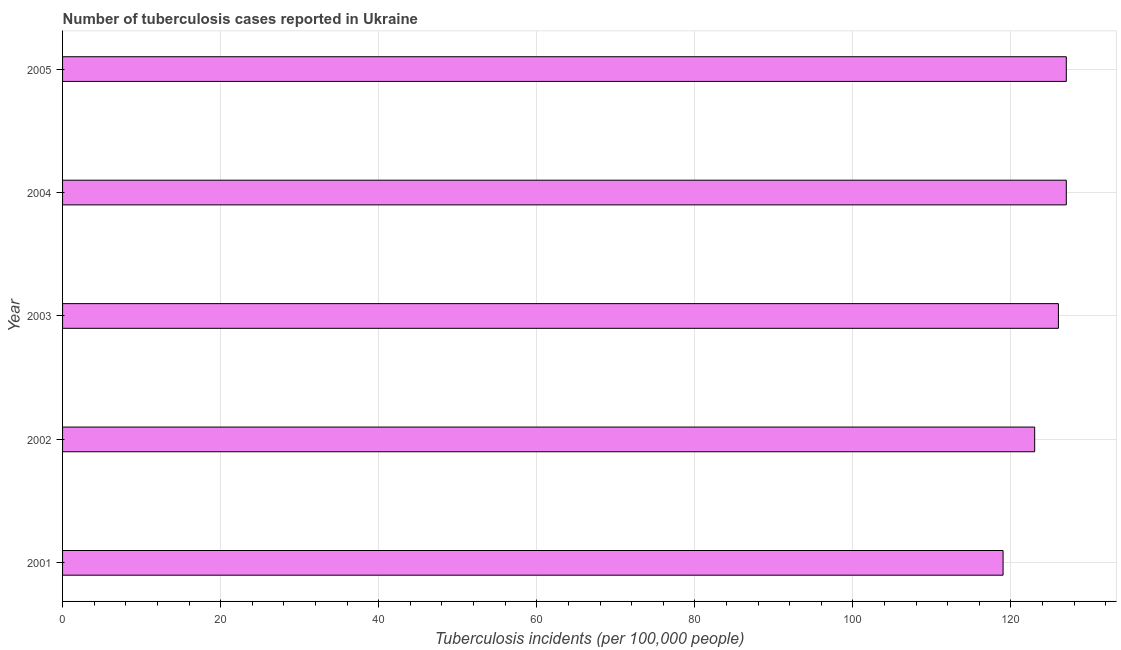Does the graph contain any zero values?
Your answer should be compact. No. Does the graph contain grids?
Provide a short and direct response. Yes. What is the title of the graph?
Ensure brevity in your answer.  Number of tuberculosis cases reported in Ukraine. What is the label or title of the X-axis?
Make the answer very short. Tuberculosis incidents (per 100,0 people). What is the number of tuberculosis incidents in 2004?
Provide a short and direct response. 127. Across all years, what is the maximum number of tuberculosis incidents?
Provide a succinct answer. 127. Across all years, what is the minimum number of tuberculosis incidents?
Provide a succinct answer. 119. In which year was the number of tuberculosis incidents minimum?
Your answer should be compact. 2001. What is the sum of the number of tuberculosis incidents?
Offer a terse response. 622. What is the average number of tuberculosis incidents per year?
Make the answer very short. 124. What is the median number of tuberculosis incidents?
Provide a succinct answer. 126. Do a majority of the years between 2001 and 2005 (inclusive) have number of tuberculosis incidents greater than 56 ?
Provide a succinct answer. Yes. Is the difference between the number of tuberculosis incidents in 2002 and 2003 greater than the difference between any two years?
Your response must be concise. No. Is the sum of the number of tuberculosis incidents in 2003 and 2004 greater than the maximum number of tuberculosis incidents across all years?
Make the answer very short. Yes. In how many years, is the number of tuberculosis incidents greater than the average number of tuberculosis incidents taken over all years?
Your response must be concise. 3. Are the values on the major ticks of X-axis written in scientific E-notation?
Offer a terse response. No. What is the Tuberculosis incidents (per 100,000 people) of 2001?
Offer a terse response. 119. What is the Tuberculosis incidents (per 100,000 people) in 2002?
Keep it short and to the point. 123. What is the Tuberculosis incidents (per 100,000 people) in 2003?
Your response must be concise. 126. What is the Tuberculosis incidents (per 100,000 people) in 2004?
Give a very brief answer. 127. What is the Tuberculosis incidents (per 100,000 people) in 2005?
Provide a short and direct response. 127. What is the difference between the Tuberculosis incidents (per 100,000 people) in 2001 and 2005?
Offer a terse response. -8. What is the difference between the Tuberculosis incidents (per 100,000 people) in 2002 and 2003?
Keep it short and to the point. -3. What is the difference between the Tuberculosis incidents (per 100,000 people) in 2002 and 2004?
Offer a very short reply. -4. What is the difference between the Tuberculosis incidents (per 100,000 people) in 2002 and 2005?
Make the answer very short. -4. What is the difference between the Tuberculosis incidents (per 100,000 people) in 2003 and 2004?
Offer a very short reply. -1. What is the difference between the Tuberculosis incidents (per 100,000 people) in 2003 and 2005?
Ensure brevity in your answer.  -1. What is the difference between the Tuberculosis incidents (per 100,000 people) in 2004 and 2005?
Make the answer very short. 0. What is the ratio of the Tuberculosis incidents (per 100,000 people) in 2001 to that in 2003?
Provide a succinct answer. 0.94. What is the ratio of the Tuberculosis incidents (per 100,000 people) in 2001 to that in 2004?
Your answer should be very brief. 0.94. What is the ratio of the Tuberculosis incidents (per 100,000 people) in 2001 to that in 2005?
Ensure brevity in your answer.  0.94. What is the ratio of the Tuberculosis incidents (per 100,000 people) in 2002 to that in 2004?
Ensure brevity in your answer.  0.97. What is the ratio of the Tuberculosis incidents (per 100,000 people) in 2003 to that in 2005?
Give a very brief answer. 0.99. What is the ratio of the Tuberculosis incidents (per 100,000 people) in 2004 to that in 2005?
Your response must be concise. 1. 